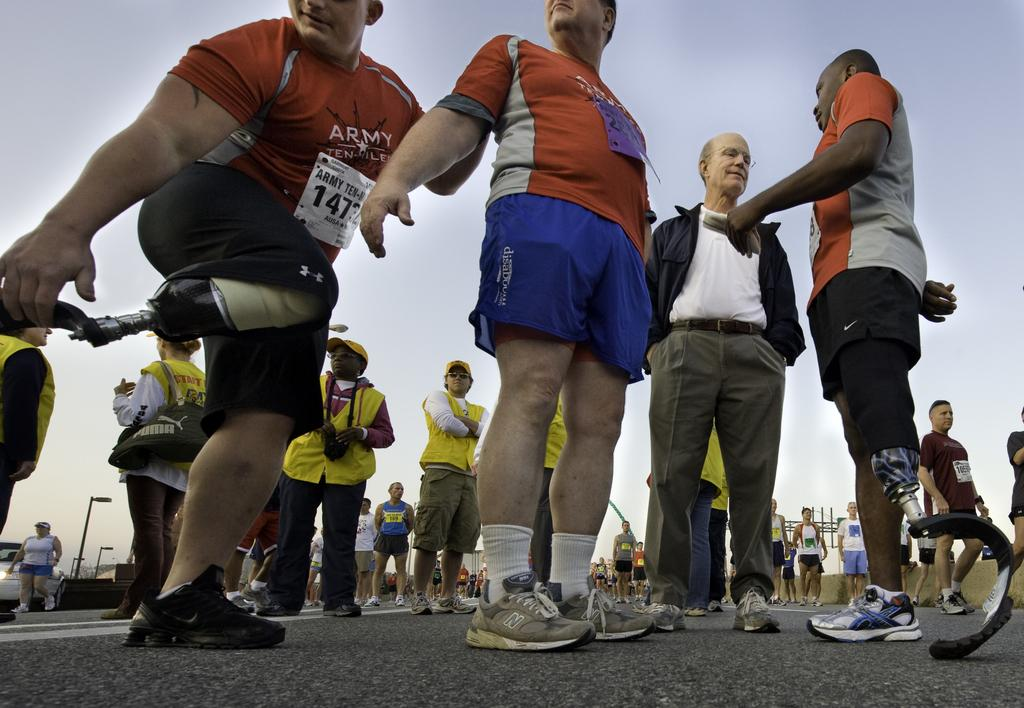How many people are in the image? There are people in the image, but the exact number is not specified. What type of footwear are the people wearing? The people in the image are wearing shoes. Can you describe any unique features of one of the individuals in the image? Yes, there is a person with a synthetic leg in the image. What type of oil can be seen dripping from the person with the synthetic leg in the image? There is no oil present in the image, and the person with the synthetic leg is not depicted as having any oil on them. 